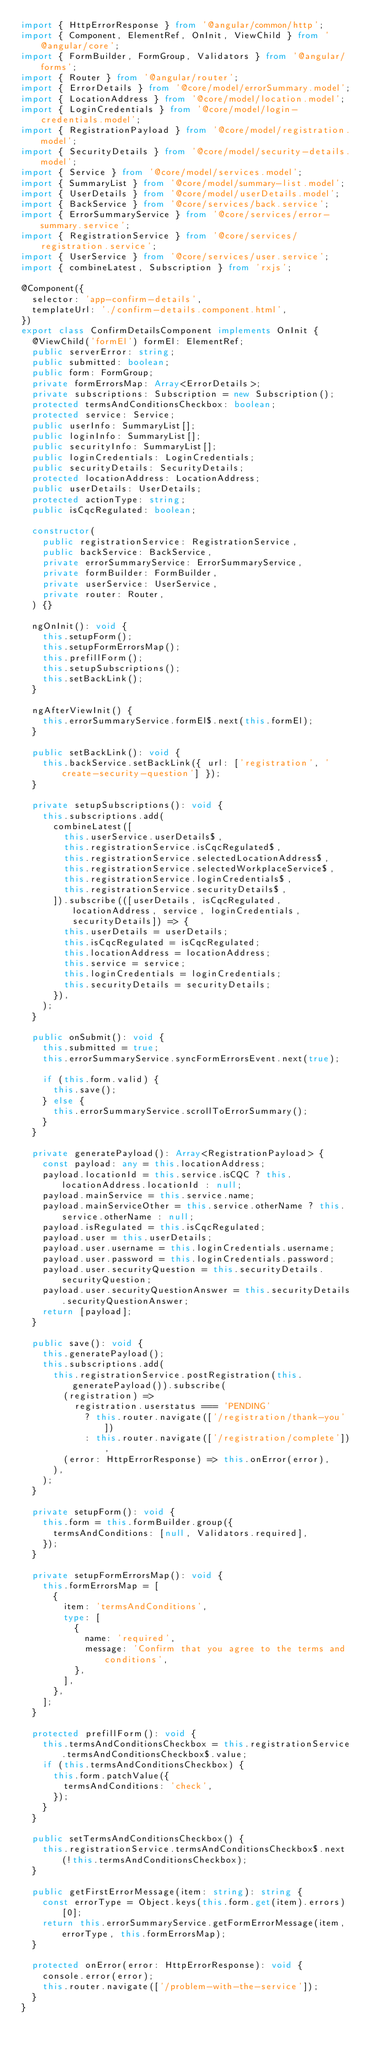<code> <loc_0><loc_0><loc_500><loc_500><_TypeScript_>import { HttpErrorResponse } from '@angular/common/http';
import { Component, ElementRef, OnInit, ViewChild } from '@angular/core';
import { FormBuilder, FormGroup, Validators } from '@angular/forms';
import { Router } from '@angular/router';
import { ErrorDetails } from '@core/model/errorSummary.model';
import { LocationAddress } from '@core/model/location.model';
import { LoginCredentials } from '@core/model/login-credentials.model';
import { RegistrationPayload } from '@core/model/registration.model';
import { SecurityDetails } from '@core/model/security-details.model';
import { Service } from '@core/model/services.model';
import { SummaryList } from '@core/model/summary-list.model';
import { UserDetails } from '@core/model/userDetails.model';
import { BackService } from '@core/services/back.service';
import { ErrorSummaryService } from '@core/services/error-summary.service';
import { RegistrationService } from '@core/services/registration.service';
import { UserService } from '@core/services/user.service';
import { combineLatest, Subscription } from 'rxjs';

@Component({
  selector: 'app-confirm-details',
  templateUrl: './confirm-details.component.html',
})
export class ConfirmDetailsComponent implements OnInit {
  @ViewChild('formEl') formEl: ElementRef;
  public serverError: string;
  public submitted: boolean;
  public form: FormGroup;
  private formErrorsMap: Array<ErrorDetails>;
  private subscriptions: Subscription = new Subscription();
  protected termsAndConditionsCheckbox: boolean;
  protected service: Service;
  public userInfo: SummaryList[];
  public loginInfo: SummaryList[];
  public securityInfo: SummaryList[];
  public loginCredentials: LoginCredentials;
  public securityDetails: SecurityDetails;
  protected locationAddress: LocationAddress;
  public userDetails: UserDetails;
  protected actionType: string;
  public isCqcRegulated: boolean;

  constructor(
    public registrationService: RegistrationService,
    public backService: BackService,
    private errorSummaryService: ErrorSummaryService,
    private formBuilder: FormBuilder,
    private userService: UserService,
    private router: Router,
  ) {}

  ngOnInit(): void {
    this.setupForm();
    this.setupFormErrorsMap();
    this.prefillForm();
    this.setupSubscriptions();
    this.setBackLink();
  }

  ngAfterViewInit() {
    this.errorSummaryService.formEl$.next(this.formEl);
  }

  public setBackLink(): void {
    this.backService.setBackLink({ url: ['registration', 'create-security-question'] });
  }

  private setupSubscriptions(): void {
    this.subscriptions.add(
      combineLatest([
        this.userService.userDetails$,
        this.registrationService.isCqcRegulated$,
        this.registrationService.selectedLocationAddress$,
        this.registrationService.selectedWorkplaceService$,
        this.registrationService.loginCredentials$,
        this.registrationService.securityDetails$,
      ]).subscribe(([userDetails, isCqcRegulated, locationAddress, service, loginCredentials, securityDetails]) => {
        this.userDetails = userDetails;
        this.isCqcRegulated = isCqcRegulated;
        this.locationAddress = locationAddress;
        this.service = service;
        this.loginCredentials = loginCredentials;
        this.securityDetails = securityDetails;
      }),
    );
  }

  public onSubmit(): void {
    this.submitted = true;
    this.errorSummaryService.syncFormErrorsEvent.next(true);

    if (this.form.valid) {
      this.save();
    } else {
      this.errorSummaryService.scrollToErrorSummary();
    }
  }

  private generatePayload(): Array<RegistrationPayload> {
    const payload: any = this.locationAddress;
    payload.locationId = this.service.isCQC ? this.locationAddress.locationId : null;
    payload.mainService = this.service.name;
    payload.mainServiceOther = this.service.otherName ? this.service.otherName : null;
    payload.isRegulated = this.isCqcRegulated;
    payload.user = this.userDetails;
    payload.user.username = this.loginCredentials.username;
    payload.user.password = this.loginCredentials.password;
    payload.user.securityQuestion = this.securityDetails.securityQuestion;
    payload.user.securityQuestionAnswer = this.securityDetails.securityQuestionAnswer;
    return [payload];
  }

  public save(): void {
    this.generatePayload();
    this.subscriptions.add(
      this.registrationService.postRegistration(this.generatePayload()).subscribe(
        (registration) =>
          registration.userstatus === 'PENDING'
            ? this.router.navigate(['/registration/thank-you'])
            : this.router.navigate(['/registration/complete']),
        (error: HttpErrorResponse) => this.onError(error),
      ),
    );
  }

  private setupForm(): void {
    this.form = this.formBuilder.group({
      termsAndConditions: [null, Validators.required],
    });
  }

  private setupFormErrorsMap(): void {
    this.formErrorsMap = [
      {
        item: 'termsAndConditions',
        type: [
          {
            name: 'required',
            message: 'Confirm that you agree to the terms and conditions',
          },
        ],
      },
    ];
  }

  protected prefillForm(): void {
    this.termsAndConditionsCheckbox = this.registrationService.termsAndConditionsCheckbox$.value;
    if (this.termsAndConditionsCheckbox) {
      this.form.patchValue({
        termsAndConditions: 'check',
      });
    }
  }

  public setTermsAndConditionsCheckbox() {
    this.registrationService.termsAndConditionsCheckbox$.next(!this.termsAndConditionsCheckbox);
  }

  public getFirstErrorMessage(item: string): string {
    const errorType = Object.keys(this.form.get(item).errors)[0];
    return this.errorSummaryService.getFormErrorMessage(item, errorType, this.formErrorsMap);
  }

  protected onError(error: HttpErrorResponse): void {
    console.error(error);
    this.router.navigate(['/problem-with-the-service']);
  }
}
</code> 